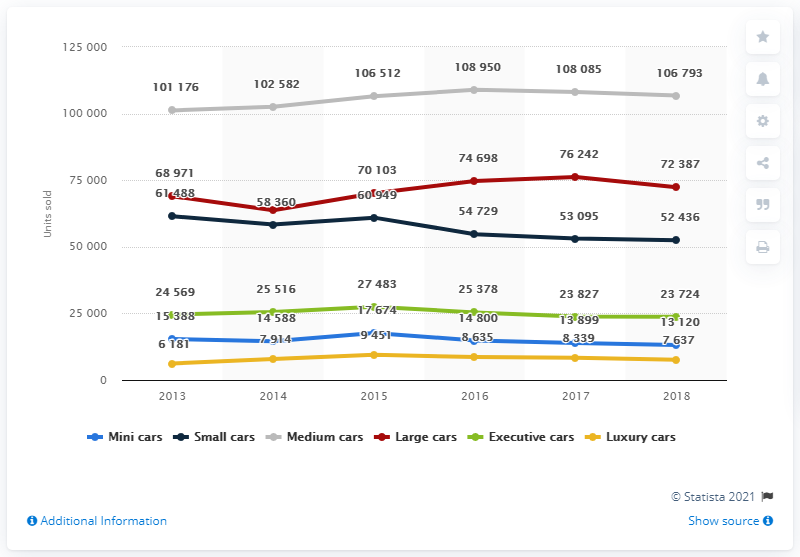Give some essential details in this illustration. In 2018, a total of 7,637 luxury personal cars were sold in Switzerland. 